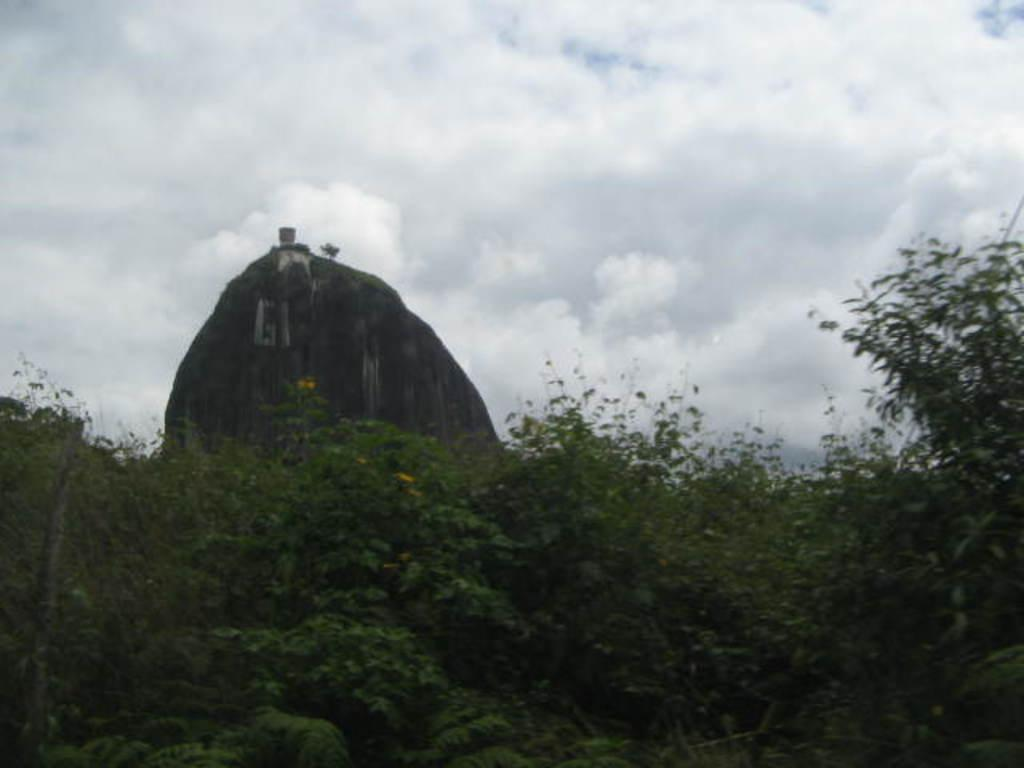What type of living organisms can be seen in the image? Plants can be seen in the image. What is visible in the background of the image? The sky is visible in the background of the image. Can you describe any other objects present in the background of the image? There are other objects present in the background of the image, but their specific details are not mentioned in the provided facts. How many eyes can be seen on the plants in the image? Plants do not have eyes, so there are no eyes visible on the plants in the image. 